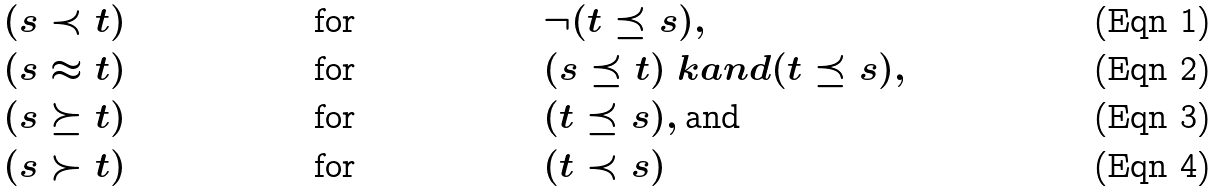Convert formula to latex. <formula><loc_0><loc_0><loc_500><loc_500>& ( s \prec t ) & & \text {for} & & \neg ( t \preceq s ) , \\ & ( s \approx t ) & & \text {for} & & ( s \preceq t ) \ k a n d ( t \preceq s ) , \\ & ( s \succeq t ) & & \text {for} & & ( t \preceq s ) , \text {and} \\ & ( s \succ t ) & & \text {for} & & ( t \prec s )</formula> 